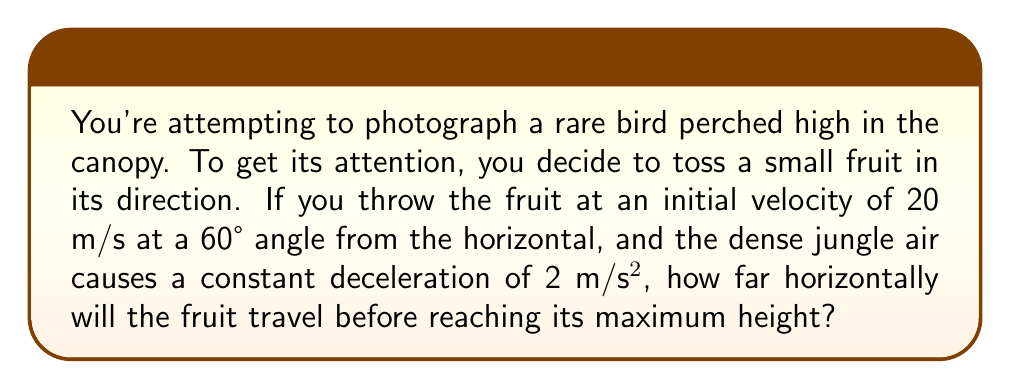What is the answer to this math problem? Let's approach this step-by-step:

1) First, we need to decompose the initial velocity into its horizontal and vertical components:

   Horizontal velocity: $v_{x0} = v_0 \cos \theta = 20 \cos 60° = 10$ m/s
   Vertical velocity: $v_{y0} = v_0 \sin \theta = 20 \sin 60° = 17.32$ m/s

2) The horizontal distance traveled is given by:

   $x = v_{x0}t$

   where $t$ is the time to reach maximum height.

3) To find $t$, we use the equation for vertical motion:

   $v_y = v_{y0} - at$

   At maximum height, $v_y = 0$, so:

   $0 = 17.32 - 2t$
   $t = 8.66$ seconds

4) Now we can calculate the horizontal distance:

   $x = v_{x0}t = 10 \cdot 8.66 = 86.6$ meters

Therefore, the fruit will travel 86.6 meters horizontally before reaching its maximum height.
Answer: 86.6 meters 